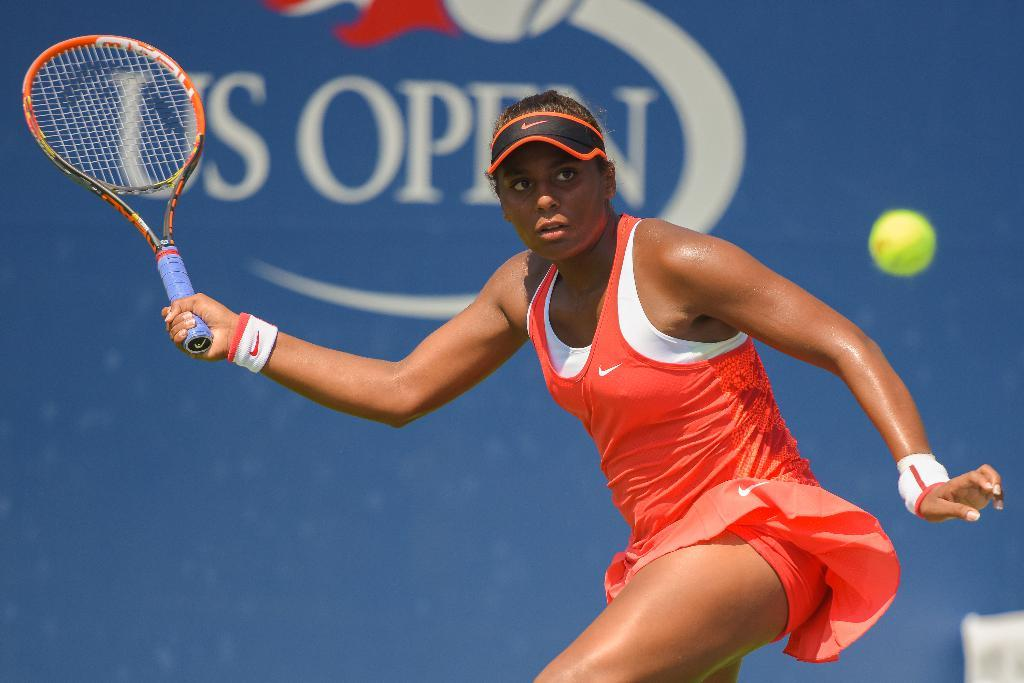Who is the main subject in the image? There is a girl in the image. What is the girl holding in her right hand? The girl is holding a tennis bat in her right hand. What color is the girl's costume? The girl is wearing a red color costume. What is the girl doing with her left hand? The girl is pointing at something, which is likely a short. What is the girl's reaction to the minister's speech in the image? There is no minister or speech present in the image, so it is not possible to determine the girl's reaction. 